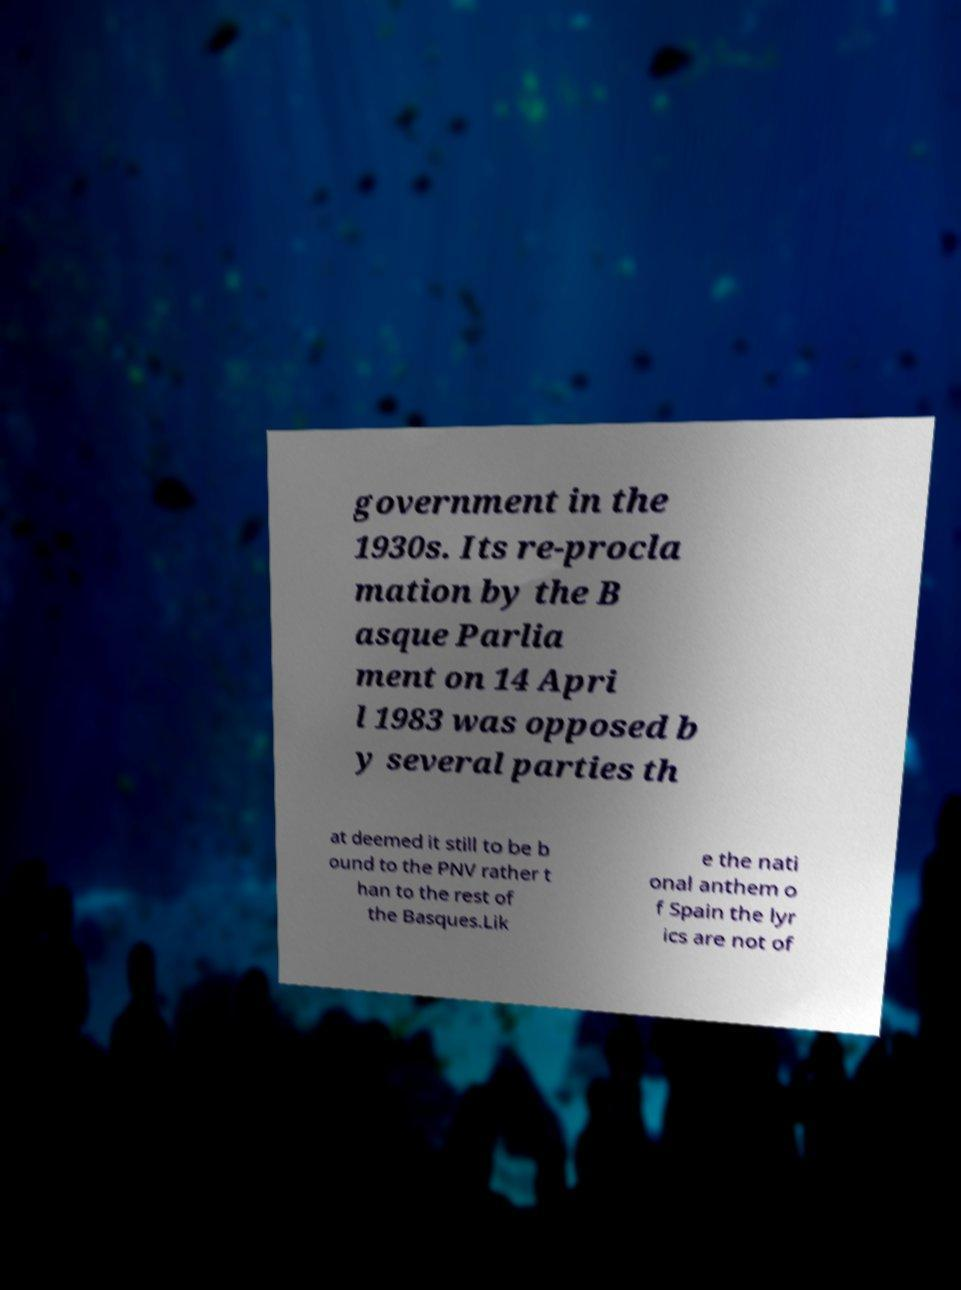For documentation purposes, I need the text within this image transcribed. Could you provide that? government in the 1930s. Its re-procla mation by the B asque Parlia ment on 14 Apri l 1983 was opposed b y several parties th at deemed it still to be b ound to the PNV rather t han to the rest of the Basques.Lik e the nati onal anthem o f Spain the lyr ics are not of 